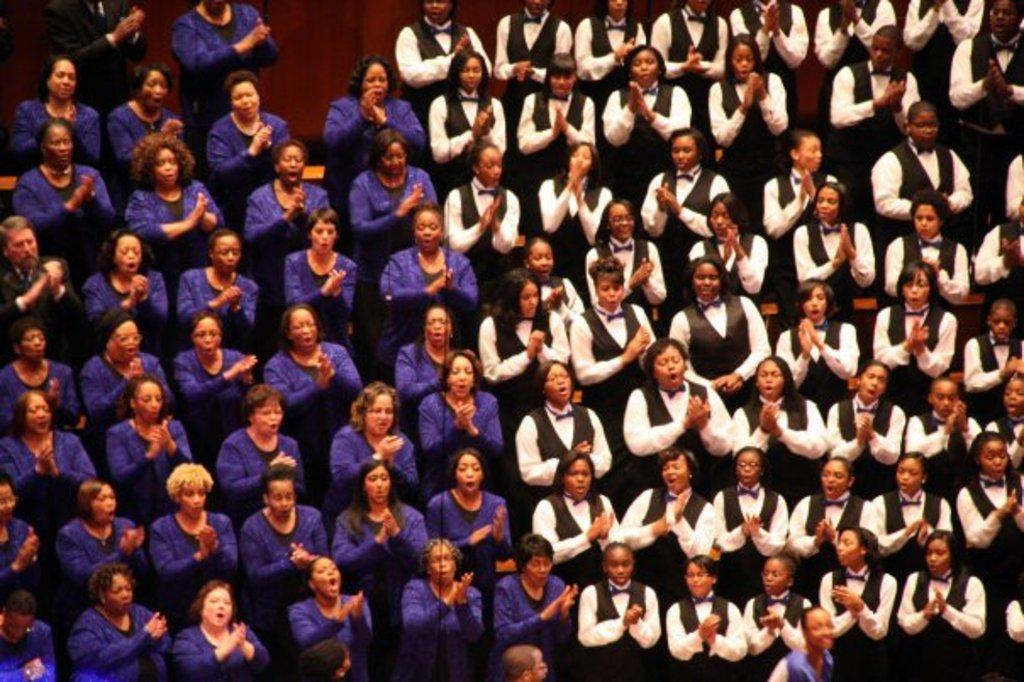What is happening in the foreground of the image? There is a crowd in the foreground of the image. What are the people in the crowd doing? The crowd is clapping. How can the women in the crowd be distinguished based on their clothing? Half of the women are wearing purple dresses, while the other half are wearing black and white dresses. What type of health issues are the people in the crowd experiencing? There is no information about the health of the people in the crowd, so we cannot determine if they are experiencing any health issues. Can you describe the arch in the image? There is no arch present in the image; it features a crowd of people clapping. 